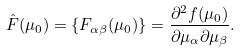<formula> <loc_0><loc_0><loc_500><loc_500>\hat { F } ( \mu _ { 0 } ) = \left \{ F _ { \alpha \beta } ( \mu _ { 0 } ) \right \} = \frac { \partial ^ { 2 } f ( \mu _ { 0 } ) } { \partial \mu _ { \alpha } \partial \mu _ { \beta } } .</formula> 